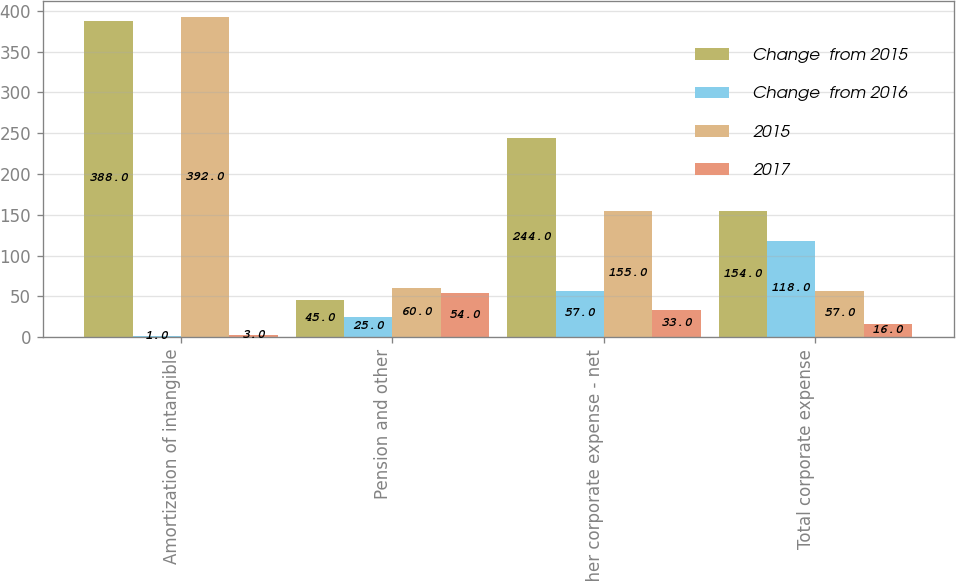Convert chart to OTSL. <chart><loc_0><loc_0><loc_500><loc_500><stacked_bar_chart><ecel><fcel>Amortization of intangible<fcel>Pension and other<fcel>Other corporate expense - net<fcel>Total corporate expense<nl><fcel>Change  from 2015<fcel>388<fcel>45<fcel>244<fcel>154<nl><fcel>Change  from 2016<fcel>1<fcel>25<fcel>57<fcel>118<nl><fcel>2015<fcel>392<fcel>60<fcel>155<fcel>57<nl><fcel>2017<fcel>3<fcel>54<fcel>33<fcel>16<nl></chart> 